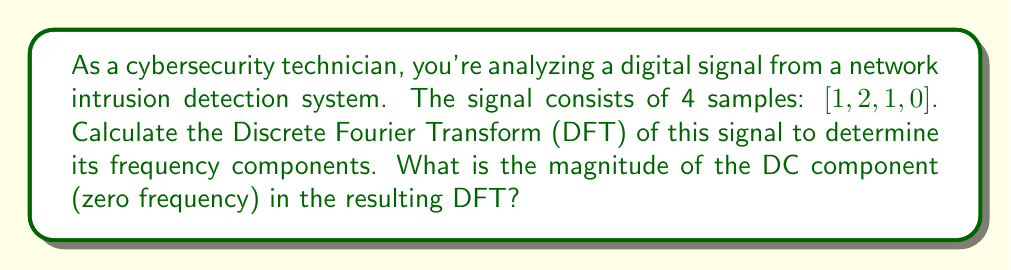Teach me how to tackle this problem. To solve this problem, we'll follow these steps:

1) The Discrete Fourier Transform (DFT) of a signal $x[n]$ of length N is given by:

   $$X[k] = \sum_{n=0}^{N-1} x[n] e^{-j2\pi kn/N}$$

   where $k = 0, 1, ..., N-1$

2) In this case, $N = 4$ and $x[n] = [1, 2, 1, 0]$

3) We need to calculate $X[0]$, which is the DC component:

   $$X[0] = \sum_{n=0}^{3} x[n] e^{-j2\pi (0)n/4} = \sum_{n=0}^{3} x[n]$$

4) Substituting the values:

   $$X[0] = 1 + 2 + 1 + 0 = 4$$

5) The magnitude of a complex number $a + bi$ is given by $\sqrt{a^2 + b^2}$. In this case, $X[0]$ is real, so its magnitude is simply its absolute value.

6) Therefore, the magnitude of the DC component is $|X[0]| = |4| = 4$

This DC component represents the average value of the signal, which is indeed $(1+2+1+0)/4 = 1$.
Answer: The magnitude of the DC component (zero frequency) in the DFT is 4. 